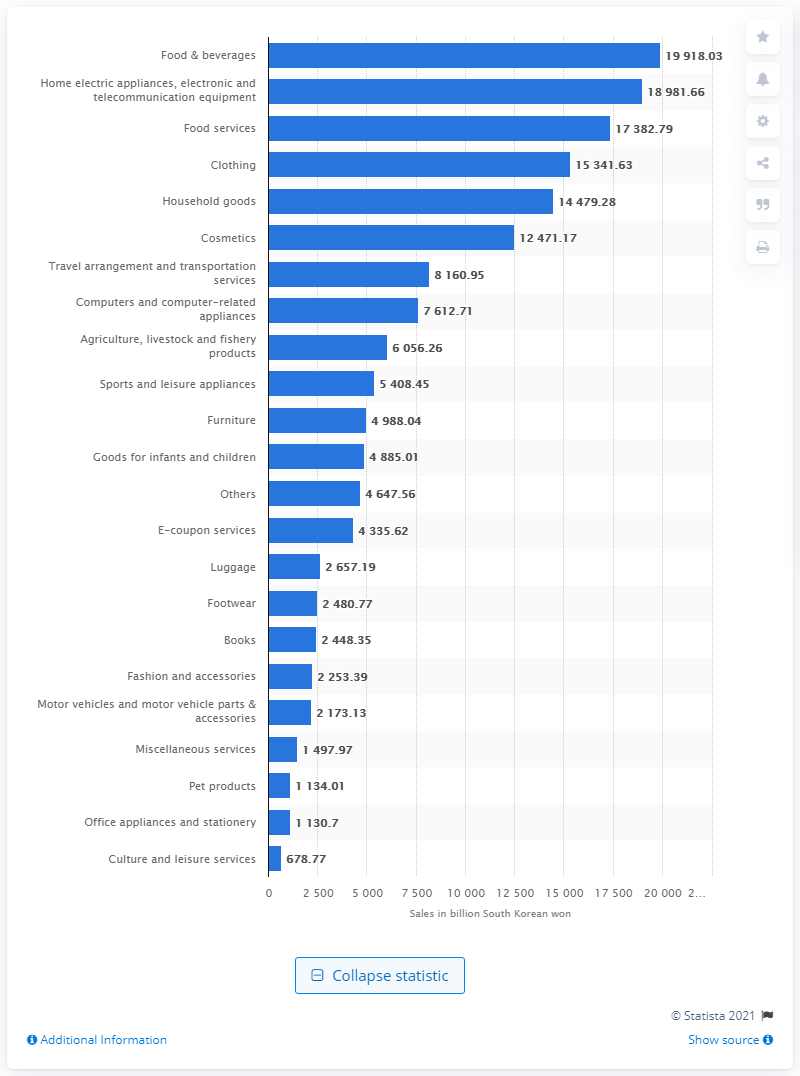Identify some key points in this picture. In 2020, online shoppers in South Korea spent a total of 19,918.03 South Korean won on food and beverages. 